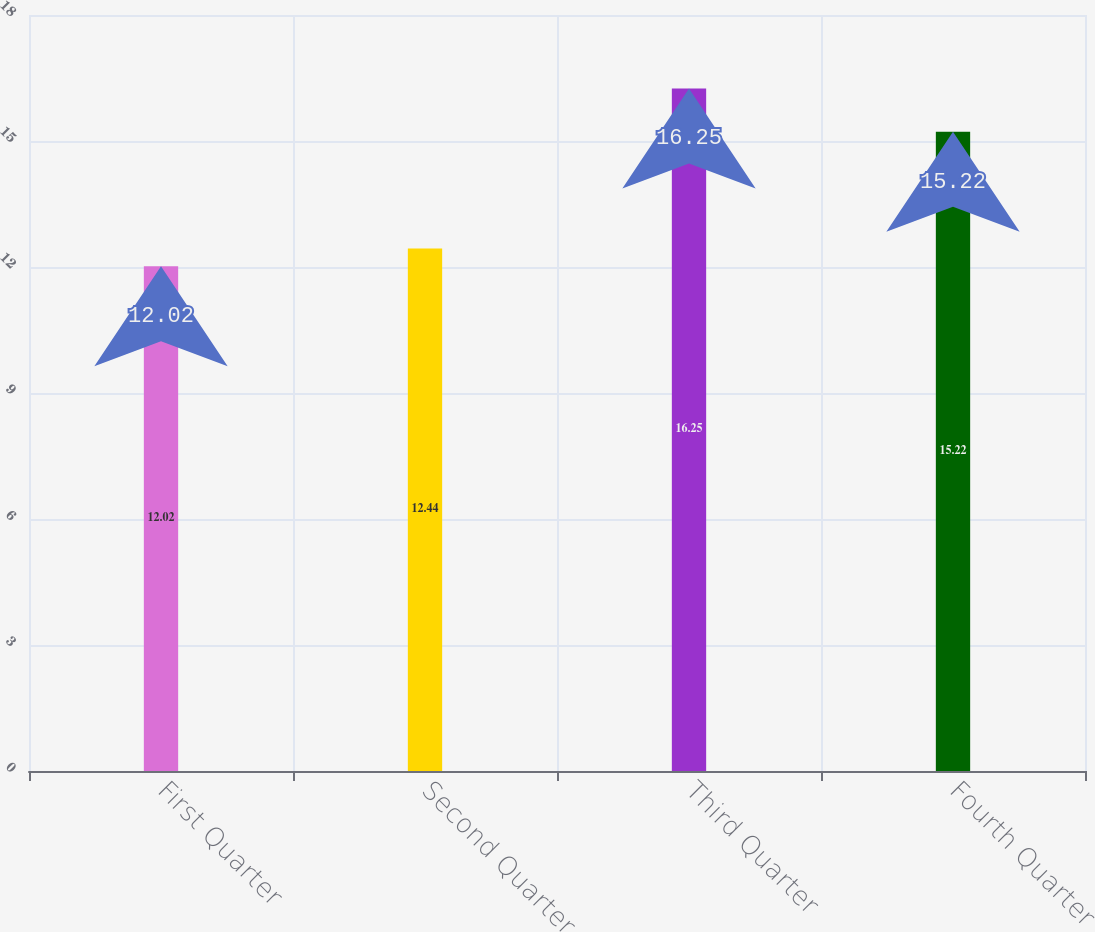Convert chart to OTSL. <chart><loc_0><loc_0><loc_500><loc_500><bar_chart><fcel>First Quarter<fcel>Second Quarter<fcel>Third Quarter<fcel>Fourth Quarter<nl><fcel>12.02<fcel>12.44<fcel>16.25<fcel>15.22<nl></chart> 